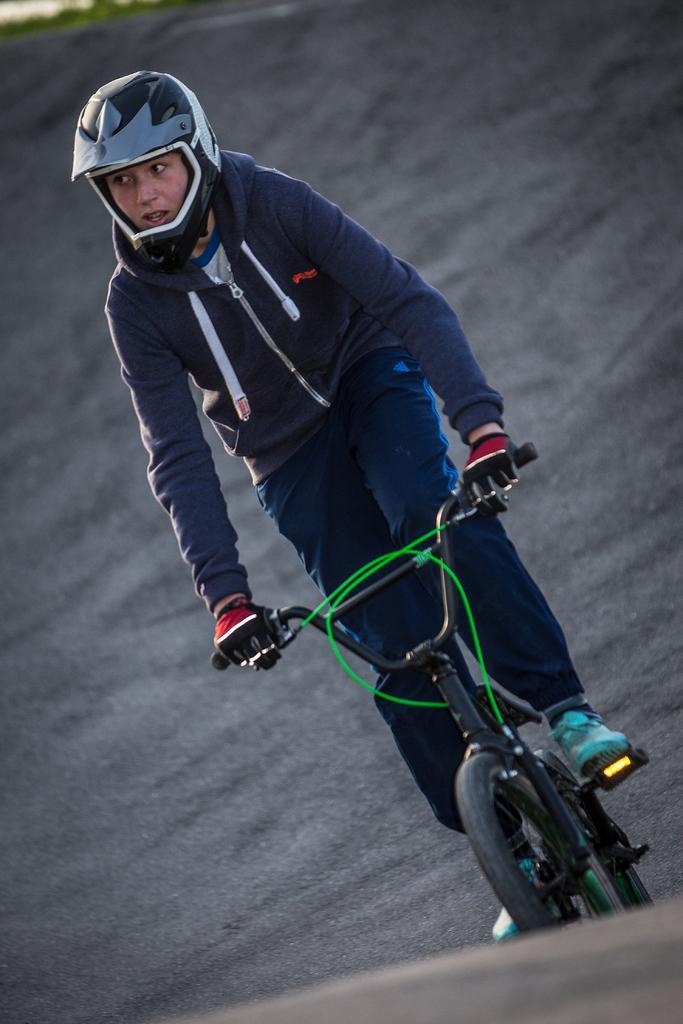How would you summarize this image in a sentence or two? In the center of the image we can see a person riding bicycle. At the bottom there is a road. 